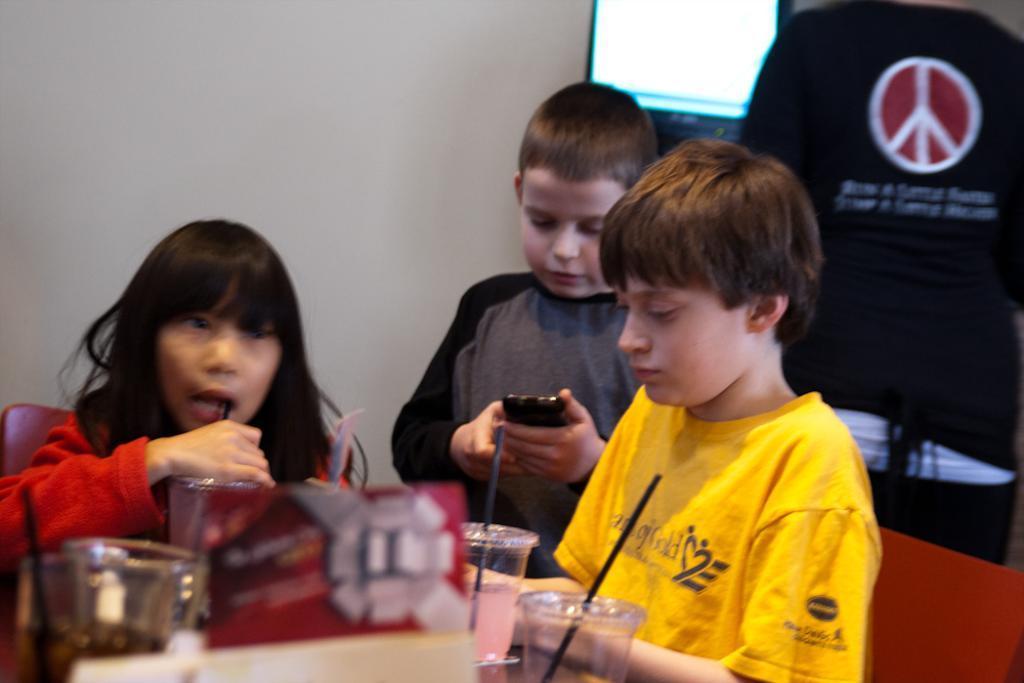How would you summarize this image in a sentence or two? In this picture we can see a few cups and straws and other objects on the table. There is a boy holding a phone in his hand. We can see a girl sitting on a chair and holding an object. We can see another boy sitting on the chair on the right side. A black T shirt is visible and a peace sign is seen on this shirt. We can see a screen and a wall in the background. 